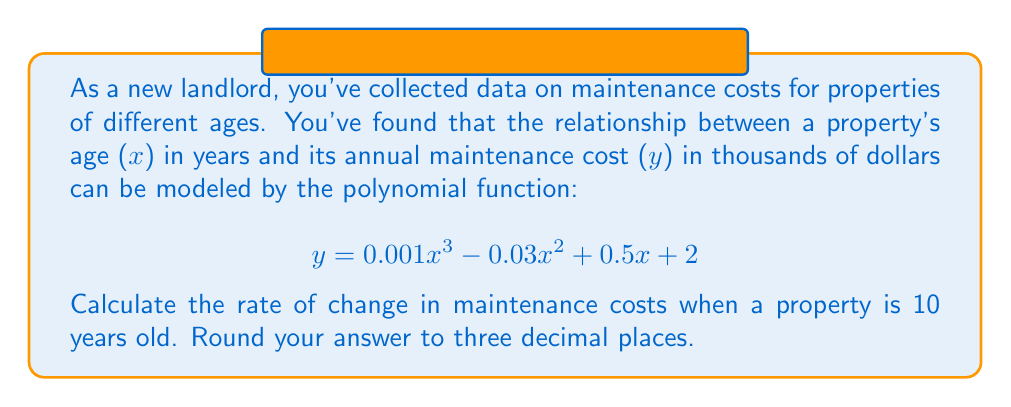Could you help me with this problem? To find the rate of change in maintenance costs at a specific age, we need to find the derivative of the given function and evaluate it at x = 10.

1. Start with the original function:
   $$ y = 0.001x^3 - 0.03x^2 + 0.5x + 2 $$

2. Find the derivative using the power rule:
   $$ \frac{dy}{dx} = 0.003x^2 - 0.06x + 0.5 $$

3. Evaluate the derivative at x = 10:
   $$ \frac{dy}{dx}\bigg|_{x=10} = 0.003(10)^2 - 0.06(10) + 0.5 $$
   $$ = 0.003(100) - 0.6 + 0.5 $$
   $$ = 0.3 - 0.6 + 0.5 $$
   $$ = 0.2 $$

4. The result, 0.2, represents the rate of change in thousands of dollars per year.

5. Convert to a more practical unit:
   $$ 0.2 \text{ thousand dollars/year} = 200 \text{ dollars/year} $$

Therefore, when a property is 10 years old, the maintenance costs are increasing at a rate of 200 dollars per year.
Answer: $200 per year 